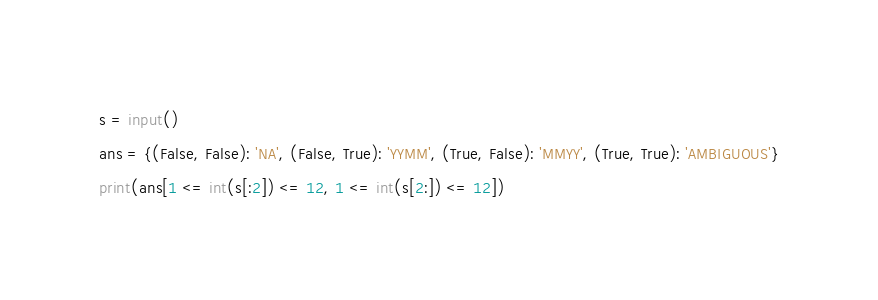<code> <loc_0><loc_0><loc_500><loc_500><_Python_>s = input()
ans = {(False, False): 'NA', (False, True): 'YYMM', (True, False): 'MMYY', (True, True): 'AMBIGUOUS'}
print(ans[1 <= int(s[:2]) <= 12, 1 <= int(s[2:]) <= 12])</code> 